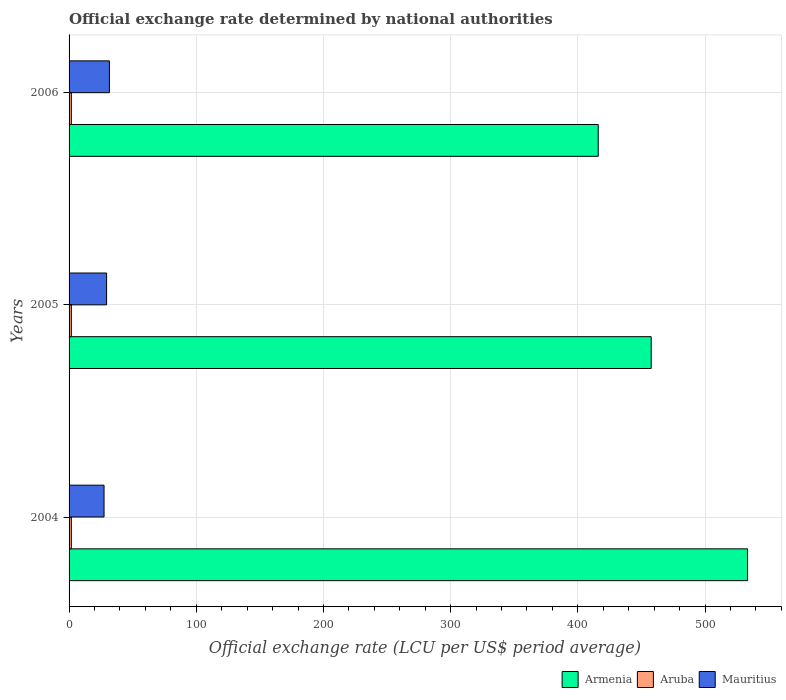Are the number of bars on each tick of the Y-axis equal?
Offer a terse response. Yes. In how many cases, is the number of bars for a given year not equal to the number of legend labels?
Give a very brief answer. 0. What is the official exchange rate in Aruba in 2005?
Make the answer very short. 1.79. Across all years, what is the maximum official exchange rate in Mauritius?
Offer a very short reply. 31.71. Across all years, what is the minimum official exchange rate in Mauritius?
Provide a succinct answer. 27.5. What is the total official exchange rate in Armenia in the graph?
Your answer should be very brief. 1407.18. What is the difference between the official exchange rate in Mauritius in 2004 and that in 2005?
Your answer should be very brief. -2. What is the difference between the official exchange rate in Armenia in 2004 and the official exchange rate in Aruba in 2006?
Provide a short and direct response. 531.66. What is the average official exchange rate in Mauritius per year?
Ensure brevity in your answer.  29.57. In the year 2004, what is the difference between the official exchange rate in Mauritius and official exchange rate in Aruba?
Your answer should be very brief. 25.71. What is the ratio of the official exchange rate in Mauritius in 2004 to that in 2006?
Provide a short and direct response. 0.87. What is the difference between the highest and the second highest official exchange rate in Aruba?
Your answer should be compact. 0. What does the 1st bar from the top in 2005 represents?
Provide a short and direct response. Mauritius. What does the 2nd bar from the bottom in 2006 represents?
Offer a very short reply. Aruba. Is it the case that in every year, the sum of the official exchange rate in Mauritius and official exchange rate in Aruba is greater than the official exchange rate in Armenia?
Give a very brief answer. No. How many bars are there?
Make the answer very short. 9. What is the difference between two consecutive major ticks on the X-axis?
Your response must be concise. 100. Does the graph contain any zero values?
Offer a very short reply. No. Where does the legend appear in the graph?
Give a very brief answer. Bottom right. How are the legend labels stacked?
Your answer should be very brief. Horizontal. What is the title of the graph?
Provide a short and direct response. Official exchange rate determined by national authorities. What is the label or title of the X-axis?
Provide a succinct answer. Official exchange rate (LCU per US$ period average). What is the label or title of the Y-axis?
Offer a very short reply. Years. What is the Official exchange rate (LCU per US$ period average) in Armenia in 2004?
Keep it short and to the point. 533.45. What is the Official exchange rate (LCU per US$ period average) in Aruba in 2004?
Your answer should be very brief. 1.79. What is the Official exchange rate (LCU per US$ period average) of Mauritius in 2004?
Ensure brevity in your answer.  27.5. What is the Official exchange rate (LCU per US$ period average) in Armenia in 2005?
Ensure brevity in your answer.  457.69. What is the Official exchange rate (LCU per US$ period average) in Aruba in 2005?
Ensure brevity in your answer.  1.79. What is the Official exchange rate (LCU per US$ period average) of Mauritius in 2005?
Ensure brevity in your answer.  29.5. What is the Official exchange rate (LCU per US$ period average) in Armenia in 2006?
Ensure brevity in your answer.  416.04. What is the Official exchange rate (LCU per US$ period average) of Aruba in 2006?
Your response must be concise. 1.79. What is the Official exchange rate (LCU per US$ period average) in Mauritius in 2006?
Keep it short and to the point. 31.71. Across all years, what is the maximum Official exchange rate (LCU per US$ period average) in Armenia?
Your response must be concise. 533.45. Across all years, what is the maximum Official exchange rate (LCU per US$ period average) in Aruba?
Offer a very short reply. 1.79. Across all years, what is the maximum Official exchange rate (LCU per US$ period average) of Mauritius?
Offer a very short reply. 31.71. Across all years, what is the minimum Official exchange rate (LCU per US$ period average) of Armenia?
Offer a terse response. 416.04. Across all years, what is the minimum Official exchange rate (LCU per US$ period average) of Aruba?
Provide a short and direct response. 1.79. Across all years, what is the minimum Official exchange rate (LCU per US$ period average) in Mauritius?
Give a very brief answer. 27.5. What is the total Official exchange rate (LCU per US$ period average) in Armenia in the graph?
Offer a terse response. 1407.18. What is the total Official exchange rate (LCU per US$ period average) of Aruba in the graph?
Offer a very short reply. 5.37. What is the total Official exchange rate (LCU per US$ period average) in Mauritius in the graph?
Your answer should be compact. 88.7. What is the difference between the Official exchange rate (LCU per US$ period average) in Armenia in 2004 and that in 2005?
Ensure brevity in your answer.  75.76. What is the difference between the Official exchange rate (LCU per US$ period average) in Aruba in 2004 and that in 2005?
Give a very brief answer. 0. What is the difference between the Official exchange rate (LCU per US$ period average) in Mauritius in 2004 and that in 2005?
Make the answer very short. -2. What is the difference between the Official exchange rate (LCU per US$ period average) of Armenia in 2004 and that in 2006?
Provide a succinct answer. 117.41. What is the difference between the Official exchange rate (LCU per US$ period average) in Aruba in 2004 and that in 2006?
Make the answer very short. 0. What is the difference between the Official exchange rate (LCU per US$ period average) of Mauritius in 2004 and that in 2006?
Your answer should be compact. -4.21. What is the difference between the Official exchange rate (LCU per US$ period average) of Armenia in 2005 and that in 2006?
Offer a terse response. 41.65. What is the difference between the Official exchange rate (LCU per US$ period average) of Aruba in 2005 and that in 2006?
Offer a very short reply. 0. What is the difference between the Official exchange rate (LCU per US$ period average) in Mauritius in 2005 and that in 2006?
Your response must be concise. -2.21. What is the difference between the Official exchange rate (LCU per US$ period average) of Armenia in 2004 and the Official exchange rate (LCU per US$ period average) of Aruba in 2005?
Keep it short and to the point. 531.66. What is the difference between the Official exchange rate (LCU per US$ period average) in Armenia in 2004 and the Official exchange rate (LCU per US$ period average) in Mauritius in 2005?
Your response must be concise. 503.95. What is the difference between the Official exchange rate (LCU per US$ period average) of Aruba in 2004 and the Official exchange rate (LCU per US$ period average) of Mauritius in 2005?
Offer a very short reply. -27.71. What is the difference between the Official exchange rate (LCU per US$ period average) of Armenia in 2004 and the Official exchange rate (LCU per US$ period average) of Aruba in 2006?
Provide a succinct answer. 531.66. What is the difference between the Official exchange rate (LCU per US$ period average) in Armenia in 2004 and the Official exchange rate (LCU per US$ period average) in Mauritius in 2006?
Provide a short and direct response. 501.74. What is the difference between the Official exchange rate (LCU per US$ period average) of Aruba in 2004 and the Official exchange rate (LCU per US$ period average) of Mauritius in 2006?
Provide a succinct answer. -29.92. What is the difference between the Official exchange rate (LCU per US$ period average) in Armenia in 2005 and the Official exchange rate (LCU per US$ period average) in Aruba in 2006?
Provide a short and direct response. 455.9. What is the difference between the Official exchange rate (LCU per US$ period average) of Armenia in 2005 and the Official exchange rate (LCU per US$ period average) of Mauritius in 2006?
Keep it short and to the point. 425.98. What is the difference between the Official exchange rate (LCU per US$ period average) in Aruba in 2005 and the Official exchange rate (LCU per US$ period average) in Mauritius in 2006?
Provide a succinct answer. -29.92. What is the average Official exchange rate (LCU per US$ period average) of Armenia per year?
Give a very brief answer. 469.06. What is the average Official exchange rate (LCU per US$ period average) of Aruba per year?
Your answer should be compact. 1.79. What is the average Official exchange rate (LCU per US$ period average) of Mauritius per year?
Your answer should be very brief. 29.57. In the year 2004, what is the difference between the Official exchange rate (LCU per US$ period average) in Armenia and Official exchange rate (LCU per US$ period average) in Aruba?
Provide a short and direct response. 531.66. In the year 2004, what is the difference between the Official exchange rate (LCU per US$ period average) of Armenia and Official exchange rate (LCU per US$ period average) of Mauritius?
Ensure brevity in your answer.  505.95. In the year 2004, what is the difference between the Official exchange rate (LCU per US$ period average) in Aruba and Official exchange rate (LCU per US$ period average) in Mauritius?
Provide a succinct answer. -25.71. In the year 2005, what is the difference between the Official exchange rate (LCU per US$ period average) of Armenia and Official exchange rate (LCU per US$ period average) of Aruba?
Make the answer very short. 455.9. In the year 2005, what is the difference between the Official exchange rate (LCU per US$ period average) in Armenia and Official exchange rate (LCU per US$ period average) in Mauritius?
Offer a terse response. 428.19. In the year 2005, what is the difference between the Official exchange rate (LCU per US$ period average) in Aruba and Official exchange rate (LCU per US$ period average) in Mauritius?
Your answer should be very brief. -27.71. In the year 2006, what is the difference between the Official exchange rate (LCU per US$ period average) in Armenia and Official exchange rate (LCU per US$ period average) in Aruba?
Your answer should be very brief. 414.25. In the year 2006, what is the difference between the Official exchange rate (LCU per US$ period average) in Armenia and Official exchange rate (LCU per US$ period average) in Mauritius?
Provide a succinct answer. 384.33. In the year 2006, what is the difference between the Official exchange rate (LCU per US$ period average) of Aruba and Official exchange rate (LCU per US$ period average) of Mauritius?
Your answer should be compact. -29.92. What is the ratio of the Official exchange rate (LCU per US$ period average) in Armenia in 2004 to that in 2005?
Provide a short and direct response. 1.17. What is the ratio of the Official exchange rate (LCU per US$ period average) in Mauritius in 2004 to that in 2005?
Ensure brevity in your answer.  0.93. What is the ratio of the Official exchange rate (LCU per US$ period average) of Armenia in 2004 to that in 2006?
Ensure brevity in your answer.  1.28. What is the ratio of the Official exchange rate (LCU per US$ period average) of Aruba in 2004 to that in 2006?
Offer a terse response. 1. What is the ratio of the Official exchange rate (LCU per US$ period average) of Mauritius in 2004 to that in 2006?
Provide a short and direct response. 0.87. What is the ratio of the Official exchange rate (LCU per US$ period average) of Armenia in 2005 to that in 2006?
Your answer should be very brief. 1.1. What is the ratio of the Official exchange rate (LCU per US$ period average) of Mauritius in 2005 to that in 2006?
Make the answer very short. 0.93. What is the difference between the highest and the second highest Official exchange rate (LCU per US$ period average) of Armenia?
Provide a short and direct response. 75.76. What is the difference between the highest and the second highest Official exchange rate (LCU per US$ period average) in Aruba?
Make the answer very short. 0. What is the difference between the highest and the second highest Official exchange rate (LCU per US$ period average) in Mauritius?
Make the answer very short. 2.21. What is the difference between the highest and the lowest Official exchange rate (LCU per US$ period average) of Armenia?
Your answer should be compact. 117.41. What is the difference between the highest and the lowest Official exchange rate (LCU per US$ period average) of Mauritius?
Your answer should be very brief. 4.21. 